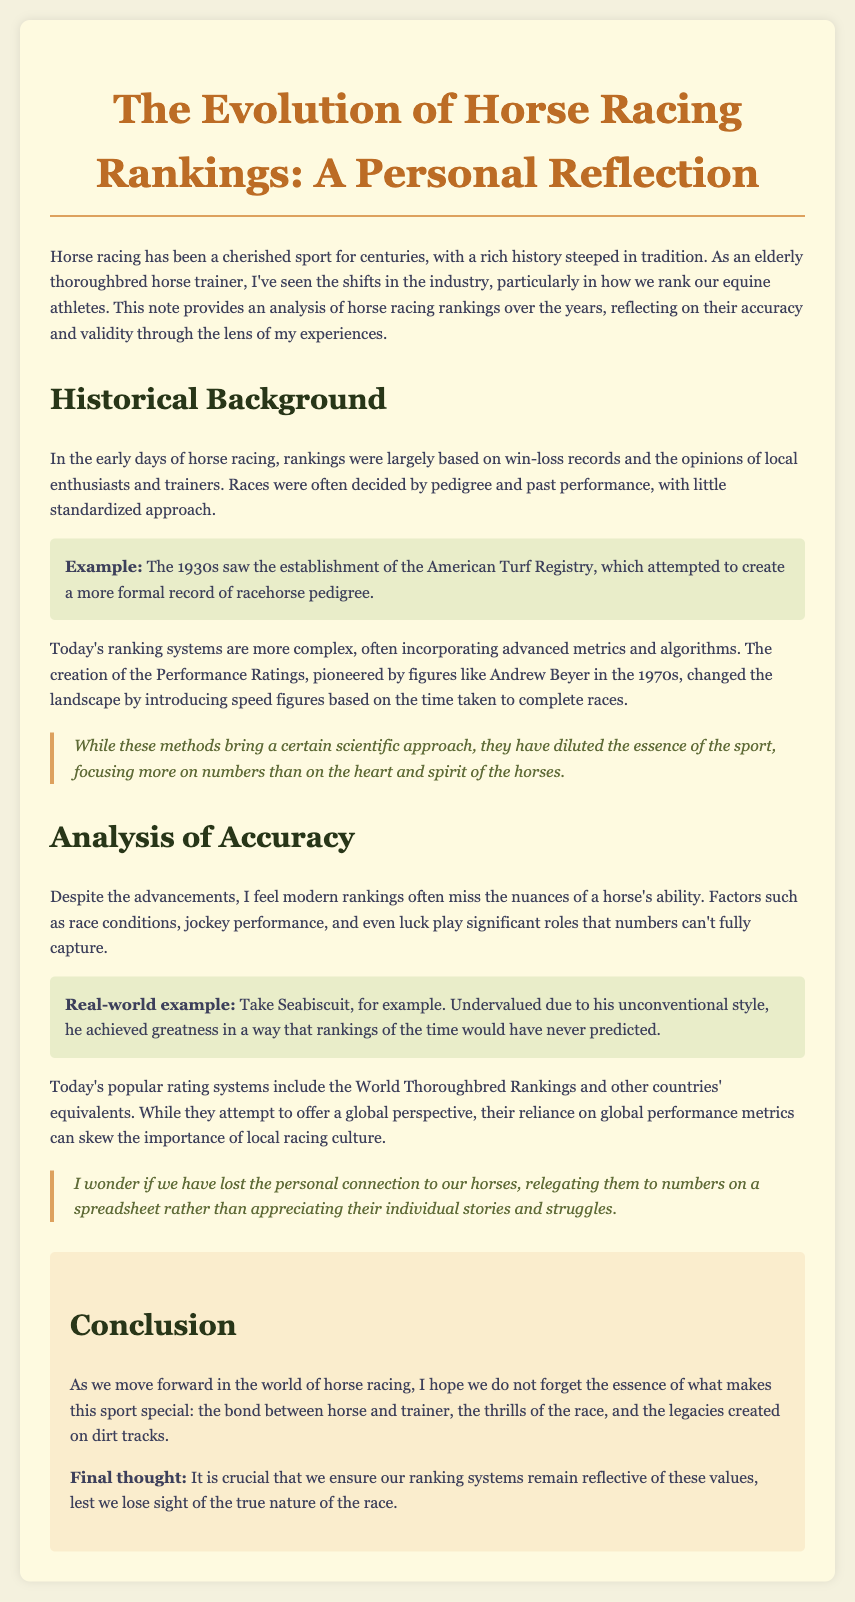What is the title of the document? The title of the document is clearly stated at the top.
Answer: The Evolution of Horse Racing Rankings: A Personal Reflection Who established the American Turf Registry in the 1930s? The establishment of the American Turf Registry is mentioned in the document but not attributed to a specific person.
Answer: Not specified What are modern ranking systems often based on? The modern ranking systems are described in terms of the techniques used, highlighting the role of advanced metrics.
Answer: Advanced metrics and algorithms Which horse is mentioned as an example of an undervalued racer? The document provides a specific example of a horse that was not recognized properly by rankings.
Answer: Seabiscuit What did the Performance Ratings introduce in the 1970s? The Performance Ratings changed how horses were evaluated by providing a certain new metric.
Answer: Speed figures What is a criticism of modern rankings according to the document? The document expresses a concern about the way rankings parse the nuances of horse racing.
Answer: They miss the nuances of a horse's ability What is a significant factor that influences race outcomes? The document lists several factors that contribute to a horse's success beyond mere statistics.
Answer: Race conditions, jockey performance, and luck What does the conclusion emphasize about horse racing? The conclusion reflects on the importance of certain values within the sport, which the author believes should be preserved.
Answer: The bond between horse and trainer 